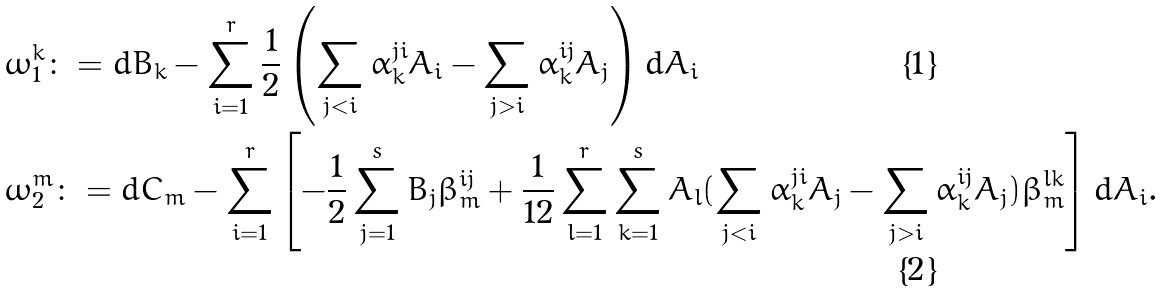<formula> <loc_0><loc_0><loc_500><loc_500>& \omega ^ { k } _ { 1 } \colon = d B _ { k } - \sum _ { i = 1 } ^ { r } \frac { 1 } { 2 } \left ( \sum _ { j < i } \alpha _ { k } ^ { j i } A _ { i } - \sum _ { j > i } \alpha _ { k } ^ { i j } A _ { j } \right ) d A _ { i } \\ & \omega ^ { m } _ { 2 } \colon = d C _ { m } - \sum _ { i = 1 } ^ { r } \left [ - \frac { 1 } { 2 } \sum _ { j = 1 } ^ { s } B _ { j } \beta _ { m } ^ { i j } + \frac { 1 } { 1 2 } \sum _ { l = 1 } ^ { r } \sum _ { k = 1 } ^ { s } A _ { l } ( \sum _ { j < i } \alpha _ { k } ^ { j i } A _ { j } - \sum _ { j > i } \alpha _ { k } ^ { i j } A _ { j } ) \beta _ { m } ^ { l k } \right ] d A _ { i } .</formula> 